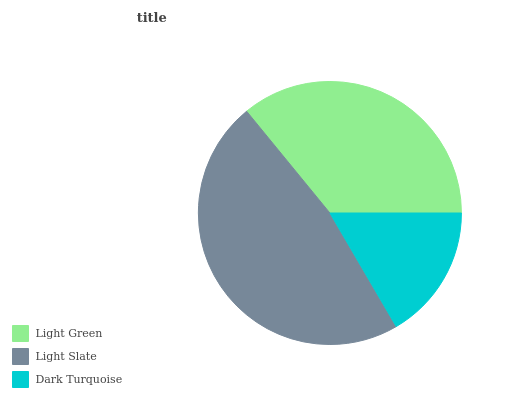Is Dark Turquoise the minimum?
Answer yes or no. Yes. Is Light Slate the maximum?
Answer yes or no. Yes. Is Light Slate the minimum?
Answer yes or no. No. Is Dark Turquoise the maximum?
Answer yes or no. No. Is Light Slate greater than Dark Turquoise?
Answer yes or no. Yes. Is Dark Turquoise less than Light Slate?
Answer yes or no. Yes. Is Dark Turquoise greater than Light Slate?
Answer yes or no. No. Is Light Slate less than Dark Turquoise?
Answer yes or no. No. Is Light Green the high median?
Answer yes or no. Yes. Is Light Green the low median?
Answer yes or no. Yes. Is Dark Turquoise the high median?
Answer yes or no. No. Is Light Slate the low median?
Answer yes or no. No. 